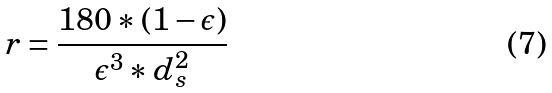Convert formula to latex. <formula><loc_0><loc_0><loc_500><loc_500>r = \frac { 1 8 0 * ( 1 - \epsilon ) } { \epsilon ^ { 3 } * d _ { s } ^ { 2 } }</formula> 